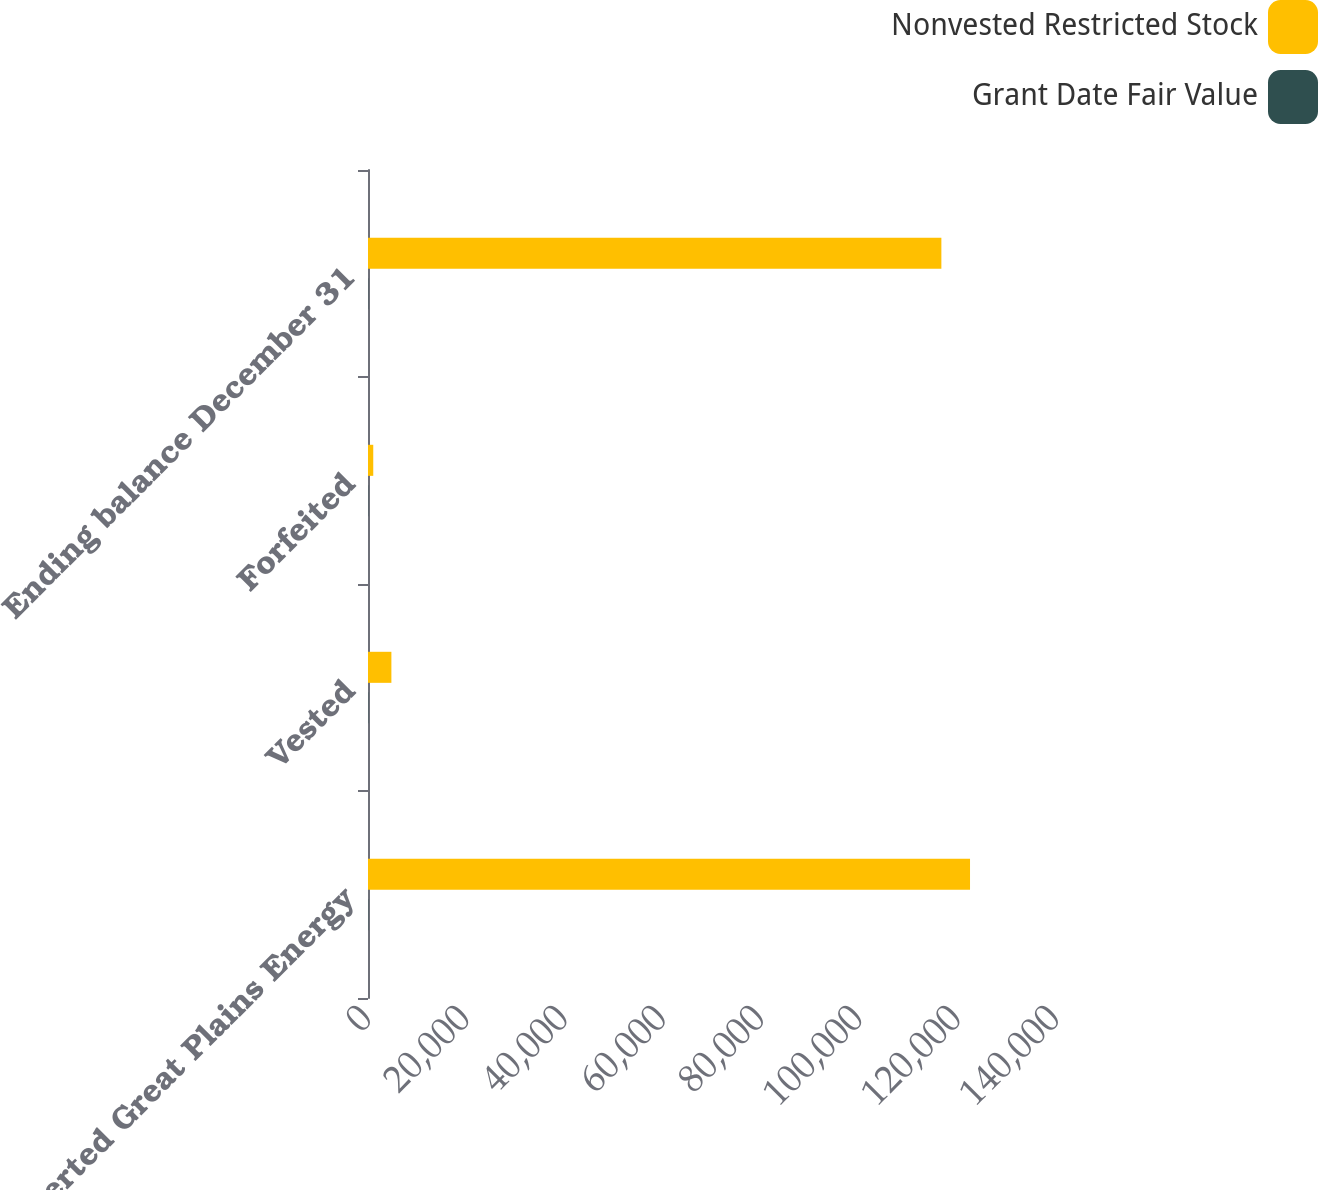<chart> <loc_0><loc_0><loc_500><loc_500><stacked_bar_chart><ecel><fcel>Converted Great Plains Energy<fcel>Vested<fcel>Forfeited<fcel>Ending balance December 31<nl><fcel>Nonvested Restricted Stock<fcel>122505<fcel>4760<fcel>1070<fcel>116675<nl><fcel>Grant Date Fair Value<fcel>54.05<fcel>54.5<fcel>54.04<fcel>54.03<nl></chart> 